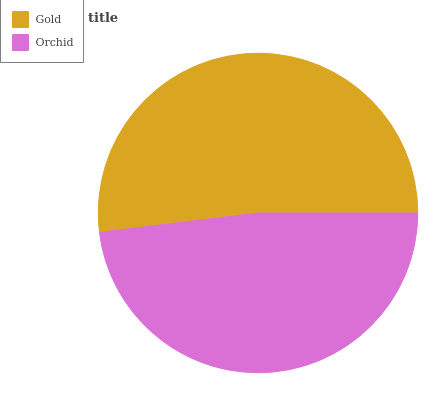Is Orchid the minimum?
Answer yes or no. Yes. Is Gold the maximum?
Answer yes or no. Yes. Is Orchid the maximum?
Answer yes or no. No. Is Gold greater than Orchid?
Answer yes or no. Yes. Is Orchid less than Gold?
Answer yes or no. Yes. Is Orchid greater than Gold?
Answer yes or no. No. Is Gold less than Orchid?
Answer yes or no. No. Is Gold the high median?
Answer yes or no. Yes. Is Orchid the low median?
Answer yes or no. Yes. Is Orchid the high median?
Answer yes or no. No. Is Gold the low median?
Answer yes or no. No. 